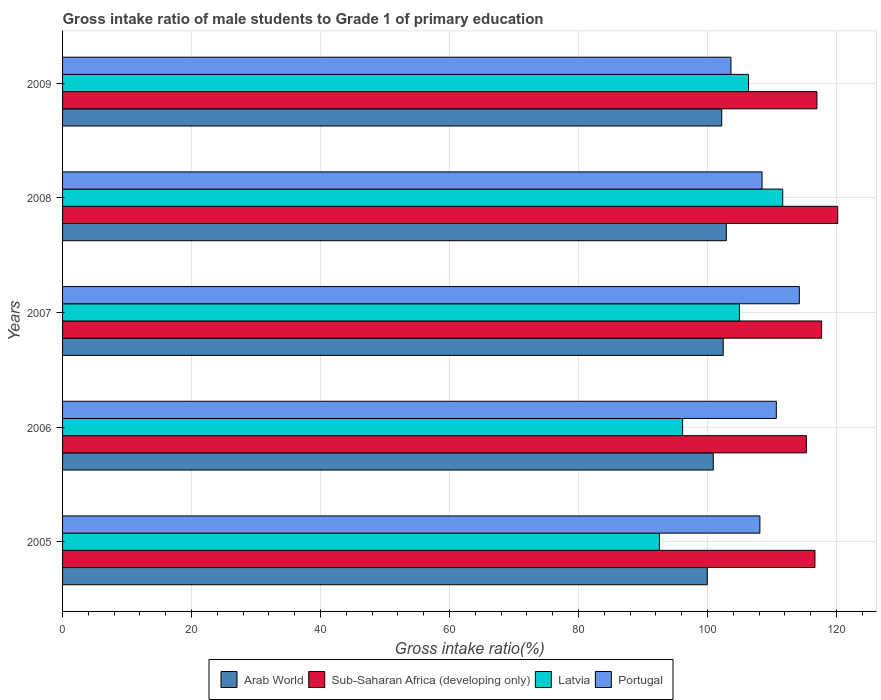How many groups of bars are there?
Your answer should be very brief. 5. How many bars are there on the 3rd tick from the top?
Offer a terse response. 4. What is the label of the 2nd group of bars from the top?
Keep it short and to the point. 2008. What is the gross intake ratio in Latvia in 2006?
Ensure brevity in your answer.  96.15. Across all years, what is the maximum gross intake ratio in Latvia?
Keep it short and to the point. 111.67. Across all years, what is the minimum gross intake ratio in Arab World?
Your response must be concise. 99.98. What is the total gross intake ratio in Portugal in the graph?
Offer a very short reply. 545.17. What is the difference between the gross intake ratio in Arab World in 2008 and that in 2009?
Provide a short and direct response. 0.72. What is the difference between the gross intake ratio in Latvia in 2006 and the gross intake ratio in Sub-Saharan Africa (developing only) in 2007?
Offer a very short reply. -21.55. What is the average gross intake ratio in Portugal per year?
Your answer should be compact. 109.03. In the year 2009, what is the difference between the gross intake ratio in Sub-Saharan Africa (developing only) and gross intake ratio in Latvia?
Give a very brief answer. 10.61. What is the ratio of the gross intake ratio in Sub-Saharan Africa (developing only) in 2005 to that in 2008?
Your response must be concise. 0.97. Is the gross intake ratio in Arab World in 2005 less than that in 2009?
Ensure brevity in your answer.  Yes. What is the difference between the highest and the second highest gross intake ratio in Latvia?
Give a very brief answer. 5.31. What is the difference between the highest and the lowest gross intake ratio in Sub-Saharan Africa (developing only)?
Make the answer very short. 4.87. In how many years, is the gross intake ratio in Arab World greater than the average gross intake ratio in Arab World taken over all years?
Keep it short and to the point. 3. Is it the case that in every year, the sum of the gross intake ratio in Arab World and gross intake ratio in Latvia is greater than the sum of gross intake ratio in Portugal and gross intake ratio in Sub-Saharan Africa (developing only)?
Give a very brief answer. No. What does the 1st bar from the top in 2006 represents?
Provide a succinct answer. Portugal. What does the 2nd bar from the bottom in 2006 represents?
Your answer should be compact. Sub-Saharan Africa (developing only). How many bars are there?
Provide a succinct answer. 20. Are all the bars in the graph horizontal?
Your response must be concise. Yes. How many years are there in the graph?
Your answer should be compact. 5. What is the difference between two consecutive major ticks on the X-axis?
Provide a short and direct response. 20. Are the values on the major ticks of X-axis written in scientific E-notation?
Your answer should be compact. No. Does the graph contain any zero values?
Offer a terse response. No. Does the graph contain grids?
Offer a very short reply. Yes. Where does the legend appear in the graph?
Keep it short and to the point. Bottom center. How many legend labels are there?
Your response must be concise. 4. How are the legend labels stacked?
Ensure brevity in your answer.  Horizontal. What is the title of the graph?
Offer a very short reply. Gross intake ratio of male students to Grade 1 of primary education. Does "South Sudan" appear as one of the legend labels in the graph?
Your answer should be very brief. No. What is the label or title of the X-axis?
Your response must be concise. Gross intake ratio(%). What is the Gross intake ratio(%) in Arab World in 2005?
Your answer should be very brief. 99.98. What is the Gross intake ratio(%) of Sub-Saharan Africa (developing only) in 2005?
Your answer should be very brief. 116.67. What is the Gross intake ratio(%) in Latvia in 2005?
Make the answer very short. 92.55. What is the Gross intake ratio(%) of Portugal in 2005?
Your answer should be compact. 108.13. What is the Gross intake ratio(%) of Arab World in 2006?
Keep it short and to the point. 100.9. What is the Gross intake ratio(%) of Sub-Saharan Africa (developing only) in 2006?
Provide a succinct answer. 115.34. What is the Gross intake ratio(%) of Latvia in 2006?
Make the answer very short. 96.15. What is the Gross intake ratio(%) in Portugal in 2006?
Provide a short and direct response. 110.68. What is the Gross intake ratio(%) of Arab World in 2007?
Your response must be concise. 102.45. What is the Gross intake ratio(%) in Sub-Saharan Africa (developing only) in 2007?
Your answer should be compact. 117.7. What is the Gross intake ratio(%) in Latvia in 2007?
Provide a succinct answer. 104.97. What is the Gross intake ratio(%) of Portugal in 2007?
Provide a succinct answer. 114.25. What is the Gross intake ratio(%) of Arab World in 2008?
Provide a succinct answer. 102.93. What is the Gross intake ratio(%) in Sub-Saharan Africa (developing only) in 2008?
Provide a succinct answer. 120.2. What is the Gross intake ratio(%) of Latvia in 2008?
Offer a terse response. 111.67. What is the Gross intake ratio(%) of Portugal in 2008?
Ensure brevity in your answer.  108.47. What is the Gross intake ratio(%) in Arab World in 2009?
Your answer should be compact. 102.21. What is the Gross intake ratio(%) in Sub-Saharan Africa (developing only) in 2009?
Offer a very short reply. 116.98. What is the Gross intake ratio(%) in Latvia in 2009?
Make the answer very short. 106.37. What is the Gross intake ratio(%) of Portugal in 2009?
Your answer should be compact. 103.64. Across all years, what is the maximum Gross intake ratio(%) in Arab World?
Your response must be concise. 102.93. Across all years, what is the maximum Gross intake ratio(%) of Sub-Saharan Africa (developing only)?
Offer a very short reply. 120.2. Across all years, what is the maximum Gross intake ratio(%) in Latvia?
Ensure brevity in your answer.  111.67. Across all years, what is the maximum Gross intake ratio(%) in Portugal?
Offer a terse response. 114.25. Across all years, what is the minimum Gross intake ratio(%) of Arab World?
Ensure brevity in your answer.  99.98. Across all years, what is the minimum Gross intake ratio(%) of Sub-Saharan Africa (developing only)?
Your response must be concise. 115.34. Across all years, what is the minimum Gross intake ratio(%) in Latvia?
Keep it short and to the point. 92.55. Across all years, what is the minimum Gross intake ratio(%) in Portugal?
Give a very brief answer. 103.64. What is the total Gross intake ratio(%) in Arab World in the graph?
Keep it short and to the point. 508.47. What is the total Gross intake ratio(%) in Sub-Saharan Africa (developing only) in the graph?
Your response must be concise. 586.89. What is the total Gross intake ratio(%) of Latvia in the graph?
Give a very brief answer. 511.71. What is the total Gross intake ratio(%) in Portugal in the graph?
Provide a short and direct response. 545.17. What is the difference between the Gross intake ratio(%) of Arab World in 2005 and that in 2006?
Your answer should be compact. -0.92. What is the difference between the Gross intake ratio(%) in Sub-Saharan Africa (developing only) in 2005 and that in 2006?
Offer a very short reply. 1.33. What is the difference between the Gross intake ratio(%) of Latvia in 2005 and that in 2006?
Your response must be concise. -3.6. What is the difference between the Gross intake ratio(%) of Portugal in 2005 and that in 2006?
Your answer should be very brief. -2.55. What is the difference between the Gross intake ratio(%) of Arab World in 2005 and that in 2007?
Provide a short and direct response. -2.47. What is the difference between the Gross intake ratio(%) in Sub-Saharan Africa (developing only) in 2005 and that in 2007?
Your response must be concise. -1.03. What is the difference between the Gross intake ratio(%) of Latvia in 2005 and that in 2007?
Your answer should be compact. -12.41. What is the difference between the Gross intake ratio(%) of Portugal in 2005 and that in 2007?
Provide a succinct answer. -6.12. What is the difference between the Gross intake ratio(%) in Arab World in 2005 and that in 2008?
Ensure brevity in your answer.  -2.95. What is the difference between the Gross intake ratio(%) in Sub-Saharan Africa (developing only) in 2005 and that in 2008?
Offer a very short reply. -3.53. What is the difference between the Gross intake ratio(%) of Latvia in 2005 and that in 2008?
Your answer should be compact. -19.12. What is the difference between the Gross intake ratio(%) in Portugal in 2005 and that in 2008?
Provide a short and direct response. -0.33. What is the difference between the Gross intake ratio(%) in Arab World in 2005 and that in 2009?
Provide a short and direct response. -2.23. What is the difference between the Gross intake ratio(%) of Sub-Saharan Africa (developing only) in 2005 and that in 2009?
Your response must be concise. -0.31. What is the difference between the Gross intake ratio(%) in Latvia in 2005 and that in 2009?
Provide a short and direct response. -13.81. What is the difference between the Gross intake ratio(%) in Portugal in 2005 and that in 2009?
Provide a short and direct response. 4.49. What is the difference between the Gross intake ratio(%) in Arab World in 2006 and that in 2007?
Your response must be concise. -1.55. What is the difference between the Gross intake ratio(%) in Sub-Saharan Africa (developing only) in 2006 and that in 2007?
Provide a short and direct response. -2.36. What is the difference between the Gross intake ratio(%) in Latvia in 2006 and that in 2007?
Your response must be concise. -8.82. What is the difference between the Gross intake ratio(%) of Portugal in 2006 and that in 2007?
Offer a terse response. -3.57. What is the difference between the Gross intake ratio(%) in Arab World in 2006 and that in 2008?
Your answer should be very brief. -2.03. What is the difference between the Gross intake ratio(%) in Sub-Saharan Africa (developing only) in 2006 and that in 2008?
Make the answer very short. -4.87. What is the difference between the Gross intake ratio(%) of Latvia in 2006 and that in 2008?
Keep it short and to the point. -15.52. What is the difference between the Gross intake ratio(%) of Portugal in 2006 and that in 2008?
Your response must be concise. 2.21. What is the difference between the Gross intake ratio(%) of Arab World in 2006 and that in 2009?
Offer a terse response. -1.31. What is the difference between the Gross intake ratio(%) of Sub-Saharan Africa (developing only) in 2006 and that in 2009?
Keep it short and to the point. -1.64. What is the difference between the Gross intake ratio(%) of Latvia in 2006 and that in 2009?
Offer a very short reply. -10.22. What is the difference between the Gross intake ratio(%) of Portugal in 2006 and that in 2009?
Offer a very short reply. 7.04. What is the difference between the Gross intake ratio(%) in Arab World in 2007 and that in 2008?
Provide a short and direct response. -0.48. What is the difference between the Gross intake ratio(%) in Sub-Saharan Africa (developing only) in 2007 and that in 2008?
Your answer should be very brief. -2.5. What is the difference between the Gross intake ratio(%) of Latvia in 2007 and that in 2008?
Your answer should be compact. -6.71. What is the difference between the Gross intake ratio(%) in Portugal in 2007 and that in 2008?
Your answer should be very brief. 5.78. What is the difference between the Gross intake ratio(%) of Arab World in 2007 and that in 2009?
Ensure brevity in your answer.  0.24. What is the difference between the Gross intake ratio(%) in Sub-Saharan Africa (developing only) in 2007 and that in 2009?
Ensure brevity in your answer.  0.72. What is the difference between the Gross intake ratio(%) of Latvia in 2007 and that in 2009?
Offer a terse response. -1.4. What is the difference between the Gross intake ratio(%) of Portugal in 2007 and that in 2009?
Provide a succinct answer. 10.61. What is the difference between the Gross intake ratio(%) of Arab World in 2008 and that in 2009?
Provide a short and direct response. 0.72. What is the difference between the Gross intake ratio(%) in Sub-Saharan Africa (developing only) in 2008 and that in 2009?
Your answer should be very brief. 3.22. What is the difference between the Gross intake ratio(%) of Latvia in 2008 and that in 2009?
Offer a very short reply. 5.31. What is the difference between the Gross intake ratio(%) of Portugal in 2008 and that in 2009?
Provide a short and direct response. 4.82. What is the difference between the Gross intake ratio(%) of Arab World in 2005 and the Gross intake ratio(%) of Sub-Saharan Africa (developing only) in 2006?
Provide a succinct answer. -15.36. What is the difference between the Gross intake ratio(%) in Arab World in 2005 and the Gross intake ratio(%) in Latvia in 2006?
Offer a very short reply. 3.83. What is the difference between the Gross intake ratio(%) in Arab World in 2005 and the Gross intake ratio(%) in Portugal in 2006?
Provide a short and direct response. -10.7. What is the difference between the Gross intake ratio(%) in Sub-Saharan Africa (developing only) in 2005 and the Gross intake ratio(%) in Latvia in 2006?
Offer a terse response. 20.52. What is the difference between the Gross intake ratio(%) in Sub-Saharan Africa (developing only) in 2005 and the Gross intake ratio(%) in Portugal in 2006?
Keep it short and to the point. 5.99. What is the difference between the Gross intake ratio(%) in Latvia in 2005 and the Gross intake ratio(%) in Portugal in 2006?
Your answer should be very brief. -18.12. What is the difference between the Gross intake ratio(%) in Arab World in 2005 and the Gross intake ratio(%) in Sub-Saharan Africa (developing only) in 2007?
Keep it short and to the point. -17.72. What is the difference between the Gross intake ratio(%) in Arab World in 2005 and the Gross intake ratio(%) in Latvia in 2007?
Give a very brief answer. -4.99. What is the difference between the Gross intake ratio(%) in Arab World in 2005 and the Gross intake ratio(%) in Portugal in 2007?
Ensure brevity in your answer.  -14.27. What is the difference between the Gross intake ratio(%) in Sub-Saharan Africa (developing only) in 2005 and the Gross intake ratio(%) in Latvia in 2007?
Your answer should be very brief. 11.7. What is the difference between the Gross intake ratio(%) in Sub-Saharan Africa (developing only) in 2005 and the Gross intake ratio(%) in Portugal in 2007?
Provide a short and direct response. 2.42. What is the difference between the Gross intake ratio(%) in Latvia in 2005 and the Gross intake ratio(%) in Portugal in 2007?
Provide a short and direct response. -21.7. What is the difference between the Gross intake ratio(%) of Arab World in 2005 and the Gross intake ratio(%) of Sub-Saharan Africa (developing only) in 2008?
Give a very brief answer. -20.22. What is the difference between the Gross intake ratio(%) in Arab World in 2005 and the Gross intake ratio(%) in Latvia in 2008?
Give a very brief answer. -11.7. What is the difference between the Gross intake ratio(%) of Arab World in 2005 and the Gross intake ratio(%) of Portugal in 2008?
Provide a succinct answer. -8.49. What is the difference between the Gross intake ratio(%) of Sub-Saharan Africa (developing only) in 2005 and the Gross intake ratio(%) of Latvia in 2008?
Your answer should be very brief. 5. What is the difference between the Gross intake ratio(%) of Sub-Saharan Africa (developing only) in 2005 and the Gross intake ratio(%) of Portugal in 2008?
Your answer should be very brief. 8.21. What is the difference between the Gross intake ratio(%) of Latvia in 2005 and the Gross intake ratio(%) of Portugal in 2008?
Your answer should be very brief. -15.91. What is the difference between the Gross intake ratio(%) of Arab World in 2005 and the Gross intake ratio(%) of Sub-Saharan Africa (developing only) in 2009?
Keep it short and to the point. -17. What is the difference between the Gross intake ratio(%) of Arab World in 2005 and the Gross intake ratio(%) of Latvia in 2009?
Offer a terse response. -6.39. What is the difference between the Gross intake ratio(%) in Arab World in 2005 and the Gross intake ratio(%) in Portugal in 2009?
Offer a terse response. -3.66. What is the difference between the Gross intake ratio(%) in Sub-Saharan Africa (developing only) in 2005 and the Gross intake ratio(%) in Latvia in 2009?
Make the answer very short. 10.3. What is the difference between the Gross intake ratio(%) of Sub-Saharan Africa (developing only) in 2005 and the Gross intake ratio(%) of Portugal in 2009?
Provide a succinct answer. 13.03. What is the difference between the Gross intake ratio(%) in Latvia in 2005 and the Gross intake ratio(%) in Portugal in 2009?
Offer a very short reply. -11.09. What is the difference between the Gross intake ratio(%) in Arab World in 2006 and the Gross intake ratio(%) in Sub-Saharan Africa (developing only) in 2007?
Offer a very short reply. -16.8. What is the difference between the Gross intake ratio(%) of Arab World in 2006 and the Gross intake ratio(%) of Latvia in 2007?
Give a very brief answer. -4.07. What is the difference between the Gross intake ratio(%) of Arab World in 2006 and the Gross intake ratio(%) of Portugal in 2007?
Give a very brief answer. -13.35. What is the difference between the Gross intake ratio(%) in Sub-Saharan Africa (developing only) in 2006 and the Gross intake ratio(%) in Latvia in 2007?
Make the answer very short. 10.37. What is the difference between the Gross intake ratio(%) of Sub-Saharan Africa (developing only) in 2006 and the Gross intake ratio(%) of Portugal in 2007?
Your answer should be compact. 1.09. What is the difference between the Gross intake ratio(%) in Latvia in 2006 and the Gross intake ratio(%) in Portugal in 2007?
Offer a very short reply. -18.1. What is the difference between the Gross intake ratio(%) in Arab World in 2006 and the Gross intake ratio(%) in Sub-Saharan Africa (developing only) in 2008?
Your answer should be very brief. -19.3. What is the difference between the Gross intake ratio(%) in Arab World in 2006 and the Gross intake ratio(%) in Latvia in 2008?
Make the answer very short. -10.77. What is the difference between the Gross intake ratio(%) of Arab World in 2006 and the Gross intake ratio(%) of Portugal in 2008?
Keep it short and to the point. -7.56. What is the difference between the Gross intake ratio(%) of Sub-Saharan Africa (developing only) in 2006 and the Gross intake ratio(%) of Latvia in 2008?
Make the answer very short. 3.66. What is the difference between the Gross intake ratio(%) in Sub-Saharan Africa (developing only) in 2006 and the Gross intake ratio(%) in Portugal in 2008?
Ensure brevity in your answer.  6.87. What is the difference between the Gross intake ratio(%) in Latvia in 2006 and the Gross intake ratio(%) in Portugal in 2008?
Give a very brief answer. -12.32. What is the difference between the Gross intake ratio(%) of Arab World in 2006 and the Gross intake ratio(%) of Sub-Saharan Africa (developing only) in 2009?
Provide a succinct answer. -16.08. What is the difference between the Gross intake ratio(%) of Arab World in 2006 and the Gross intake ratio(%) of Latvia in 2009?
Your response must be concise. -5.47. What is the difference between the Gross intake ratio(%) of Arab World in 2006 and the Gross intake ratio(%) of Portugal in 2009?
Offer a very short reply. -2.74. What is the difference between the Gross intake ratio(%) in Sub-Saharan Africa (developing only) in 2006 and the Gross intake ratio(%) in Latvia in 2009?
Provide a succinct answer. 8.97. What is the difference between the Gross intake ratio(%) in Sub-Saharan Africa (developing only) in 2006 and the Gross intake ratio(%) in Portugal in 2009?
Offer a very short reply. 11.7. What is the difference between the Gross intake ratio(%) in Latvia in 2006 and the Gross intake ratio(%) in Portugal in 2009?
Give a very brief answer. -7.49. What is the difference between the Gross intake ratio(%) in Arab World in 2007 and the Gross intake ratio(%) in Sub-Saharan Africa (developing only) in 2008?
Ensure brevity in your answer.  -17.75. What is the difference between the Gross intake ratio(%) of Arab World in 2007 and the Gross intake ratio(%) of Latvia in 2008?
Make the answer very short. -9.23. What is the difference between the Gross intake ratio(%) of Arab World in 2007 and the Gross intake ratio(%) of Portugal in 2008?
Give a very brief answer. -6.02. What is the difference between the Gross intake ratio(%) in Sub-Saharan Africa (developing only) in 2007 and the Gross intake ratio(%) in Latvia in 2008?
Provide a succinct answer. 6.03. What is the difference between the Gross intake ratio(%) of Sub-Saharan Africa (developing only) in 2007 and the Gross intake ratio(%) of Portugal in 2008?
Your answer should be very brief. 9.24. What is the difference between the Gross intake ratio(%) in Latvia in 2007 and the Gross intake ratio(%) in Portugal in 2008?
Your answer should be very brief. -3.5. What is the difference between the Gross intake ratio(%) in Arab World in 2007 and the Gross intake ratio(%) in Sub-Saharan Africa (developing only) in 2009?
Provide a short and direct response. -14.53. What is the difference between the Gross intake ratio(%) in Arab World in 2007 and the Gross intake ratio(%) in Latvia in 2009?
Provide a succinct answer. -3.92. What is the difference between the Gross intake ratio(%) of Arab World in 2007 and the Gross intake ratio(%) of Portugal in 2009?
Give a very brief answer. -1.19. What is the difference between the Gross intake ratio(%) in Sub-Saharan Africa (developing only) in 2007 and the Gross intake ratio(%) in Latvia in 2009?
Keep it short and to the point. 11.33. What is the difference between the Gross intake ratio(%) of Sub-Saharan Africa (developing only) in 2007 and the Gross intake ratio(%) of Portugal in 2009?
Offer a very short reply. 14.06. What is the difference between the Gross intake ratio(%) of Latvia in 2007 and the Gross intake ratio(%) of Portugal in 2009?
Your response must be concise. 1.32. What is the difference between the Gross intake ratio(%) in Arab World in 2008 and the Gross intake ratio(%) in Sub-Saharan Africa (developing only) in 2009?
Give a very brief answer. -14.05. What is the difference between the Gross intake ratio(%) of Arab World in 2008 and the Gross intake ratio(%) of Latvia in 2009?
Your response must be concise. -3.44. What is the difference between the Gross intake ratio(%) of Arab World in 2008 and the Gross intake ratio(%) of Portugal in 2009?
Give a very brief answer. -0.71. What is the difference between the Gross intake ratio(%) in Sub-Saharan Africa (developing only) in 2008 and the Gross intake ratio(%) in Latvia in 2009?
Your answer should be very brief. 13.83. What is the difference between the Gross intake ratio(%) of Sub-Saharan Africa (developing only) in 2008 and the Gross intake ratio(%) of Portugal in 2009?
Offer a terse response. 16.56. What is the difference between the Gross intake ratio(%) of Latvia in 2008 and the Gross intake ratio(%) of Portugal in 2009?
Your answer should be compact. 8.03. What is the average Gross intake ratio(%) in Arab World per year?
Give a very brief answer. 101.69. What is the average Gross intake ratio(%) of Sub-Saharan Africa (developing only) per year?
Offer a terse response. 117.38. What is the average Gross intake ratio(%) of Latvia per year?
Offer a very short reply. 102.34. What is the average Gross intake ratio(%) in Portugal per year?
Your response must be concise. 109.03. In the year 2005, what is the difference between the Gross intake ratio(%) in Arab World and Gross intake ratio(%) in Sub-Saharan Africa (developing only)?
Your answer should be very brief. -16.69. In the year 2005, what is the difference between the Gross intake ratio(%) in Arab World and Gross intake ratio(%) in Latvia?
Your response must be concise. 7.43. In the year 2005, what is the difference between the Gross intake ratio(%) of Arab World and Gross intake ratio(%) of Portugal?
Provide a short and direct response. -8.15. In the year 2005, what is the difference between the Gross intake ratio(%) of Sub-Saharan Africa (developing only) and Gross intake ratio(%) of Latvia?
Your answer should be very brief. 24.12. In the year 2005, what is the difference between the Gross intake ratio(%) in Sub-Saharan Africa (developing only) and Gross intake ratio(%) in Portugal?
Give a very brief answer. 8.54. In the year 2005, what is the difference between the Gross intake ratio(%) of Latvia and Gross intake ratio(%) of Portugal?
Give a very brief answer. -15.58. In the year 2006, what is the difference between the Gross intake ratio(%) in Arab World and Gross intake ratio(%) in Sub-Saharan Africa (developing only)?
Keep it short and to the point. -14.44. In the year 2006, what is the difference between the Gross intake ratio(%) of Arab World and Gross intake ratio(%) of Latvia?
Keep it short and to the point. 4.75. In the year 2006, what is the difference between the Gross intake ratio(%) of Arab World and Gross intake ratio(%) of Portugal?
Provide a succinct answer. -9.78. In the year 2006, what is the difference between the Gross intake ratio(%) of Sub-Saharan Africa (developing only) and Gross intake ratio(%) of Latvia?
Offer a terse response. 19.19. In the year 2006, what is the difference between the Gross intake ratio(%) of Sub-Saharan Africa (developing only) and Gross intake ratio(%) of Portugal?
Ensure brevity in your answer.  4.66. In the year 2006, what is the difference between the Gross intake ratio(%) in Latvia and Gross intake ratio(%) in Portugal?
Ensure brevity in your answer.  -14.53. In the year 2007, what is the difference between the Gross intake ratio(%) in Arab World and Gross intake ratio(%) in Sub-Saharan Africa (developing only)?
Your response must be concise. -15.25. In the year 2007, what is the difference between the Gross intake ratio(%) of Arab World and Gross intake ratio(%) of Latvia?
Keep it short and to the point. -2.52. In the year 2007, what is the difference between the Gross intake ratio(%) in Arab World and Gross intake ratio(%) in Portugal?
Offer a very short reply. -11.8. In the year 2007, what is the difference between the Gross intake ratio(%) of Sub-Saharan Africa (developing only) and Gross intake ratio(%) of Latvia?
Your answer should be very brief. 12.74. In the year 2007, what is the difference between the Gross intake ratio(%) in Sub-Saharan Africa (developing only) and Gross intake ratio(%) in Portugal?
Your response must be concise. 3.45. In the year 2007, what is the difference between the Gross intake ratio(%) in Latvia and Gross intake ratio(%) in Portugal?
Provide a short and direct response. -9.28. In the year 2008, what is the difference between the Gross intake ratio(%) in Arab World and Gross intake ratio(%) in Sub-Saharan Africa (developing only)?
Offer a terse response. -17.27. In the year 2008, what is the difference between the Gross intake ratio(%) in Arab World and Gross intake ratio(%) in Latvia?
Your answer should be very brief. -8.74. In the year 2008, what is the difference between the Gross intake ratio(%) of Arab World and Gross intake ratio(%) of Portugal?
Provide a succinct answer. -5.54. In the year 2008, what is the difference between the Gross intake ratio(%) of Sub-Saharan Africa (developing only) and Gross intake ratio(%) of Latvia?
Ensure brevity in your answer.  8.53. In the year 2008, what is the difference between the Gross intake ratio(%) of Sub-Saharan Africa (developing only) and Gross intake ratio(%) of Portugal?
Make the answer very short. 11.74. In the year 2008, what is the difference between the Gross intake ratio(%) in Latvia and Gross intake ratio(%) in Portugal?
Provide a succinct answer. 3.21. In the year 2009, what is the difference between the Gross intake ratio(%) in Arab World and Gross intake ratio(%) in Sub-Saharan Africa (developing only)?
Offer a very short reply. -14.77. In the year 2009, what is the difference between the Gross intake ratio(%) in Arab World and Gross intake ratio(%) in Latvia?
Your answer should be compact. -4.16. In the year 2009, what is the difference between the Gross intake ratio(%) in Arab World and Gross intake ratio(%) in Portugal?
Give a very brief answer. -1.43. In the year 2009, what is the difference between the Gross intake ratio(%) in Sub-Saharan Africa (developing only) and Gross intake ratio(%) in Latvia?
Ensure brevity in your answer.  10.61. In the year 2009, what is the difference between the Gross intake ratio(%) of Sub-Saharan Africa (developing only) and Gross intake ratio(%) of Portugal?
Ensure brevity in your answer.  13.34. In the year 2009, what is the difference between the Gross intake ratio(%) in Latvia and Gross intake ratio(%) in Portugal?
Provide a succinct answer. 2.73. What is the ratio of the Gross intake ratio(%) in Arab World in 2005 to that in 2006?
Offer a terse response. 0.99. What is the ratio of the Gross intake ratio(%) in Sub-Saharan Africa (developing only) in 2005 to that in 2006?
Your answer should be very brief. 1.01. What is the ratio of the Gross intake ratio(%) of Latvia in 2005 to that in 2006?
Provide a succinct answer. 0.96. What is the ratio of the Gross intake ratio(%) of Portugal in 2005 to that in 2006?
Make the answer very short. 0.98. What is the ratio of the Gross intake ratio(%) of Arab World in 2005 to that in 2007?
Ensure brevity in your answer.  0.98. What is the ratio of the Gross intake ratio(%) in Latvia in 2005 to that in 2007?
Provide a short and direct response. 0.88. What is the ratio of the Gross intake ratio(%) in Portugal in 2005 to that in 2007?
Offer a very short reply. 0.95. What is the ratio of the Gross intake ratio(%) in Arab World in 2005 to that in 2008?
Your answer should be very brief. 0.97. What is the ratio of the Gross intake ratio(%) in Sub-Saharan Africa (developing only) in 2005 to that in 2008?
Your answer should be compact. 0.97. What is the ratio of the Gross intake ratio(%) in Latvia in 2005 to that in 2008?
Give a very brief answer. 0.83. What is the ratio of the Gross intake ratio(%) in Portugal in 2005 to that in 2008?
Ensure brevity in your answer.  1. What is the ratio of the Gross intake ratio(%) in Arab World in 2005 to that in 2009?
Provide a succinct answer. 0.98. What is the ratio of the Gross intake ratio(%) in Latvia in 2005 to that in 2009?
Keep it short and to the point. 0.87. What is the ratio of the Gross intake ratio(%) in Portugal in 2005 to that in 2009?
Provide a short and direct response. 1.04. What is the ratio of the Gross intake ratio(%) of Arab World in 2006 to that in 2007?
Keep it short and to the point. 0.98. What is the ratio of the Gross intake ratio(%) of Sub-Saharan Africa (developing only) in 2006 to that in 2007?
Provide a short and direct response. 0.98. What is the ratio of the Gross intake ratio(%) in Latvia in 2006 to that in 2007?
Provide a succinct answer. 0.92. What is the ratio of the Gross intake ratio(%) in Portugal in 2006 to that in 2007?
Offer a very short reply. 0.97. What is the ratio of the Gross intake ratio(%) of Arab World in 2006 to that in 2008?
Keep it short and to the point. 0.98. What is the ratio of the Gross intake ratio(%) in Sub-Saharan Africa (developing only) in 2006 to that in 2008?
Provide a succinct answer. 0.96. What is the ratio of the Gross intake ratio(%) in Latvia in 2006 to that in 2008?
Provide a succinct answer. 0.86. What is the ratio of the Gross intake ratio(%) in Portugal in 2006 to that in 2008?
Your answer should be very brief. 1.02. What is the ratio of the Gross intake ratio(%) in Arab World in 2006 to that in 2009?
Your answer should be compact. 0.99. What is the ratio of the Gross intake ratio(%) of Sub-Saharan Africa (developing only) in 2006 to that in 2009?
Offer a very short reply. 0.99. What is the ratio of the Gross intake ratio(%) in Latvia in 2006 to that in 2009?
Your answer should be compact. 0.9. What is the ratio of the Gross intake ratio(%) in Portugal in 2006 to that in 2009?
Your answer should be compact. 1.07. What is the ratio of the Gross intake ratio(%) of Arab World in 2007 to that in 2008?
Your answer should be very brief. 1. What is the ratio of the Gross intake ratio(%) of Sub-Saharan Africa (developing only) in 2007 to that in 2008?
Your response must be concise. 0.98. What is the ratio of the Gross intake ratio(%) of Latvia in 2007 to that in 2008?
Your answer should be very brief. 0.94. What is the ratio of the Gross intake ratio(%) in Portugal in 2007 to that in 2008?
Your answer should be compact. 1.05. What is the ratio of the Gross intake ratio(%) of Arab World in 2007 to that in 2009?
Offer a terse response. 1. What is the ratio of the Gross intake ratio(%) in Sub-Saharan Africa (developing only) in 2007 to that in 2009?
Keep it short and to the point. 1.01. What is the ratio of the Gross intake ratio(%) of Portugal in 2007 to that in 2009?
Ensure brevity in your answer.  1.1. What is the ratio of the Gross intake ratio(%) of Sub-Saharan Africa (developing only) in 2008 to that in 2009?
Provide a succinct answer. 1.03. What is the ratio of the Gross intake ratio(%) in Latvia in 2008 to that in 2009?
Provide a succinct answer. 1.05. What is the ratio of the Gross intake ratio(%) of Portugal in 2008 to that in 2009?
Your response must be concise. 1.05. What is the difference between the highest and the second highest Gross intake ratio(%) in Arab World?
Offer a terse response. 0.48. What is the difference between the highest and the second highest Gross intake ratio(%) in Sub-Saharan Africa (developing only)?
Offer a terse response. 2.5. What is the difference between the highest and the second highest Gross intake ratio(%) of Latvia?
Offer a very short reply. 5.31. What is the difference between the highest and the second highest Gross intake ratio(%) in Portugal?
Offer a terse response. 3.57. What is the difference between the highest and the lowest Gross intake ratio(%) of Arab World?
Ensure brevity in your answer.  2.95. What is the difference between the highest and the lowest Gross intake ratio(%) of Sub-Saharan Africa (developing only)?
Your answer should be compact. 4.87. What is the difference between the highest and the lowest Gross intake ratio(%) in Latvia?
Provide a succinct answer. 19.12. What is the difference between the highest and the lowest Gross intake ratio(%) in Portugal?
Give a very brief answer. 10.61. 